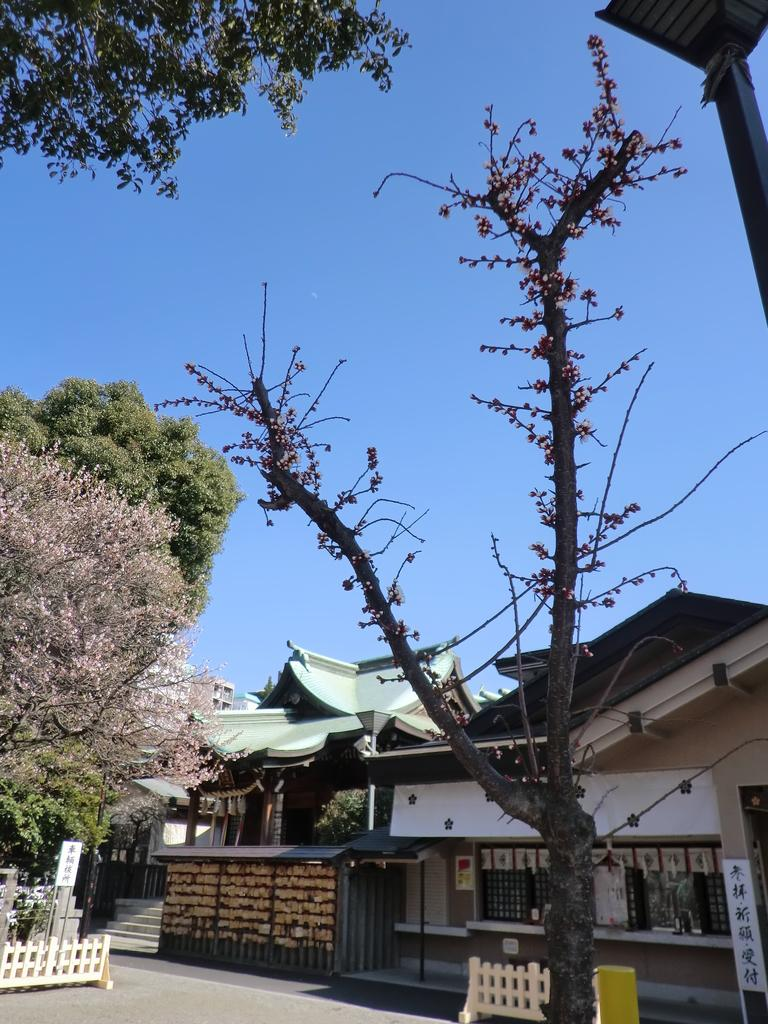What type of structures are present in the image? There are houses in the image. What other natural elements can be seen in the image? There are trees in the image. What is visible at the top of the image? The sky is visible at the top of the image and appears to be clear. How many planes can be seen flying over the island in the image? There is no island or planes present in the image; it features houses and trees. What type of cloud is blocking the sun in the image? There is no cloud blocking the sun in the image; the sky is clear. 